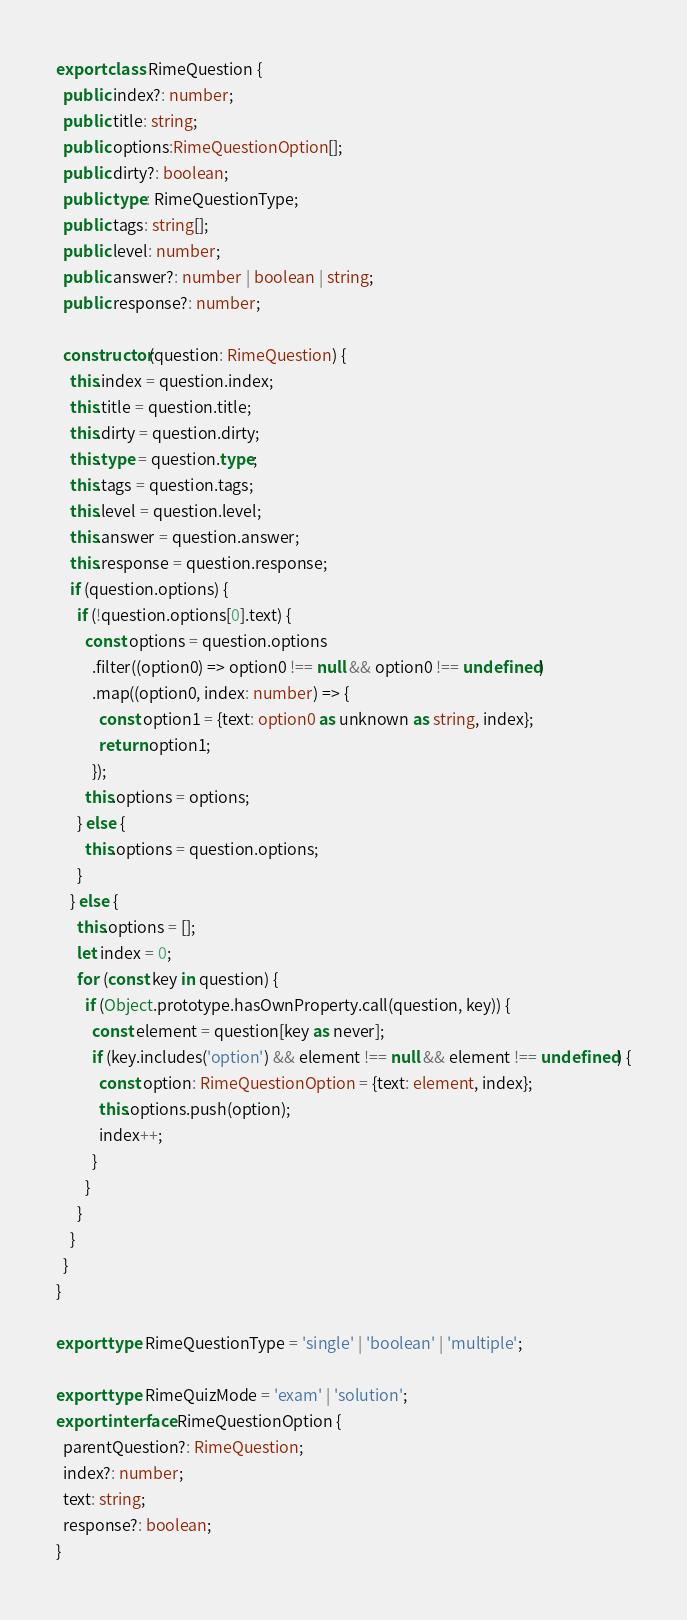Convert code to text. <code><loc_0><loc_0><loc_500><loc_500><_TypeScript_>export class RimeQuestion {
  public index?: number;
  public title: string;
  public options:RimeQuestionOption[];
  public dirty?: boolean;
  public type: RimeQuestionType;
  public tags: string[];
  public level: number;
  public answer?: number | boolean | string;
  public response?: number;

  constructor(question: RimeQuestion) {
    this.index = question.index;
    this.title = question.title;
    this.dirty = question.dirty;
    this.type = question.type;
    this.tags = question.tags;
    this.level = question.level;
    this.answer = question.answer;
    this.response = question.response;
    if (question.options) {
      if (!question.options[0].text) {
        const options = question.options
          .filter((option0) => option0 !== null && option0 !== undefined)
          .map((option0, index: number) => {
            const option1 = {text: option0 as unknown as string, index};
            return option1;
          });
        this.options = options;
      } else {
        this.options = question.options;
      }
    } else {
      this.options = [];
      let index = 0;
      for (const key in question) {
        if (Object.prototype.hasOwnProperty.call(question, key)) {
          const element = question[key as never];
          if (key.includes('option') && element !== null && element !== undefined) {
            const option: RimeQuestionOption = {text: element, index};
            this.options.push(option);
            index++;
          }
        }
      }
    }
  }
}

export type RimeQuestionType = 'single' | 'boolean' | 'multiple';

export type RimeQuizMode = 'exam' | 'solution';
export interface RimeQuestionOption {
  parentQuestion?: RimeQuestion;
  index?: number;
  text: string;
  response?: boolean;
}
</code> 